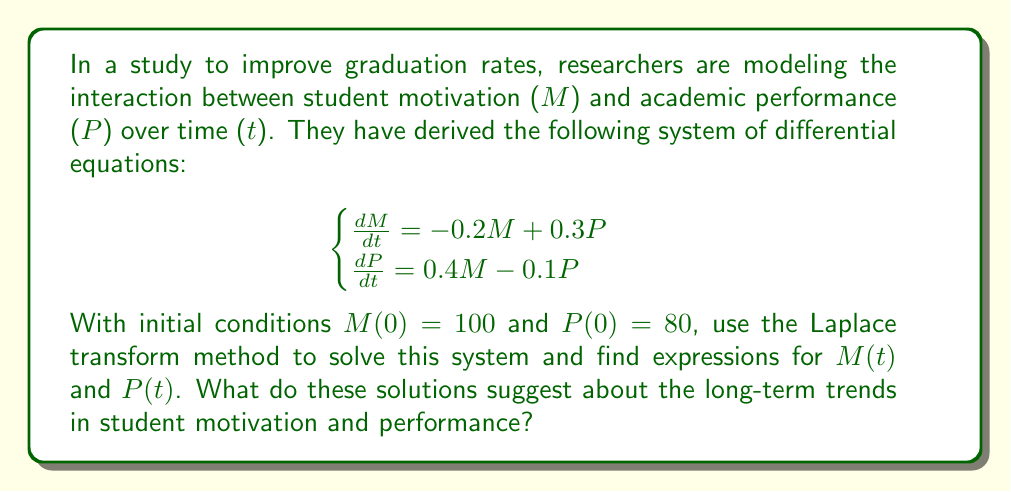What is the answer to this math problem? Let's solve this step-by-step using the Laplace transform method:

1) First, we take the Laplace transform of both equations:

   $$\begin{cases}
   s\mathcal{L}\{M\} - M(0) = -0.2\mathcal{L}\{M\} + 0.3\mathcal{L}\{P\} \\
   s\mathcal{L}\{P\} - P(0) = 0.4\mathcal{L}\{M\} - 0.1\mathcal{L}\{P\}
   \end{cases}$$

2) Let $\mathcal{L}\{M\} = \bar{M}$ and $\mathcal{L}\{P\} = \bar{P}$. Substituting the initial conditions:

   $$\begin{cases}
   s\bar{M} - 100 = -0.2\bar{M} + 0.3\bar{P} \\
   s\bar{P} - 80 = 0.4\bar{M} - 0.1\bar{P}
   \end{cases}$$

3) Rearrange the equations:

   $$\begin{cases}
   (s+0.2)\bar{M} - 0.3\bar{P} = 100 \\
   -0.4\bar{M} + (s+0.1)\bar{P} = 80
   \end{cases}$$

4) Solve this system using Cramer's rule:

   $$\Delta = \begin{vmatrix}
   s+0.2 & -0.3 \\
   -0.4 & s+0.1
   \end{vmatrix} = (s+0.2)(s+0.1) + 0.12 = s^2 + 0.3s + 0.14$$

   $$\bar{M} = \frac{1}{\Delta}\begin{vmatrix}
   100 & -0.3 \\
   80 & s+0.1
   \end{vmatrix} = \frac{100(s+0.1) + 24}{s^2 + 0.3s + 0.14}$$

   $$\bar{P} = \frac{1}{\Delta}\begin{vmatrix}
   s+0.2 & 100 \\
   -0.4 & 80
   \end{vmatrix} = \frac{80(s+0.2) + 40}{s^2 + 0.3s + 0.14}$$

5) Simplify:

   $$\bar{M} = \frac{100s + 34}{s^2 + 0.3s + 0.14}$$
   
   $$\bar{P} = \frac{80s + 56}{s^2 + 0.3s + 0.14}$$

6) To find the inverse Laplace transform, we need to factor the denominator:

   $s^2 + 0.3s + 0.14 = (s + 0.2)(s + 0.1)$

7) Using partial fraction decomposition:

   $$\bar{M} = \frac{A}{s + 0.2} + \frac{B}{s + 0.1}$$
   $$\bar{P} = \frac{C}{s + 0.2} + \frac{D}{s + 0.1}$$

   Solving for A, B, C, and D:

   $$A = 90, B = 10, C = 60, D = 20$$

8) Taking the inverse Laplace transform:

   $$M(t) = 90e^{-0.2t} + 10e^{-0.1t}$$
   $$P(t) = 60e^{-0.2t} + 20e^{-0.1t}$$

These solutions suggest that both motivation and performance will decrease over time, but at different rates. The long-term trend (as t approaches infinity) shows that both M(t) and P(t) will approach zero, indicating a potential decline in both motivation and performance if no interventions are made.
Answer: $$M(t) = 90e^{-0.2t} + 10e^{-0.1t}$$
$$P(t) = 60e^{-0.2t} + 20e^{-0.1t}$$ 